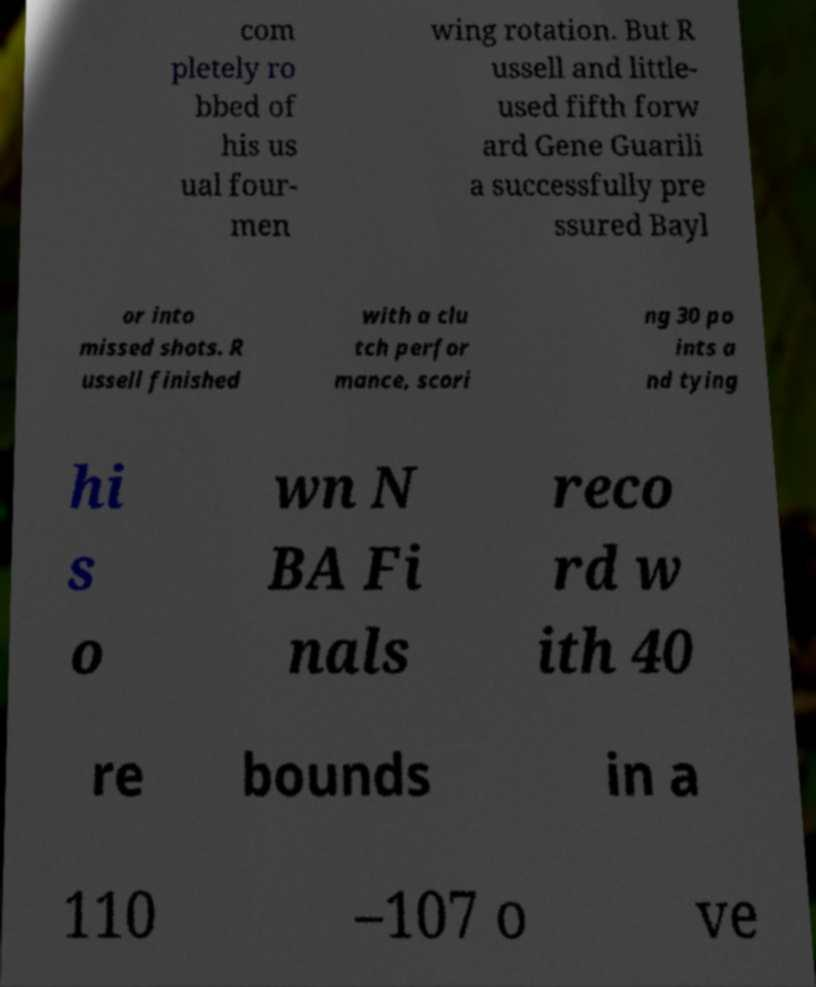Could you extract and type out the text from this image? com pletely ro bbed of his us ual four- men wing rotation. But R ussell and little- used fifth forw ard Gene Guarili a successfully pre ssured Bayl or into missed shots. R ussell finished with a clu tch perfor mance, scori ng 30 po ints a nd tying hi s o wn N BA Fi nals reco rd w ith 40 re bounds in a 110 –107 o ve 